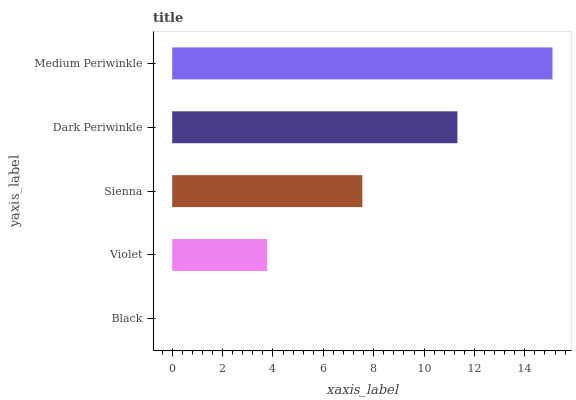Is Black the minimum?
Answer yes or no. Yes. Is Medium Periwinkle the maximum?
Answer yes or no. Yes. Is Violet the minimum?
Answer yes or no. No. Is Violet the maximum?
Answer yes or no. No. Is Violet greater than Black?
Answer yes or no. Yes. Is Black less than Violet?
Answer yes or no. Yes. Is Black greater than Violet?
Answer yes or no. No. Is Violet less than Black?
Answer yes or no. No. Is Sienna the high median?
Answer yes or no. Yes. Is Sienna the low median?
Answer yes or no. Yes. Is Dark Periwinkle the high median?
Answer yes or no. No. Is Medium Periwinkle the low median?
Answer yes or no. No. 